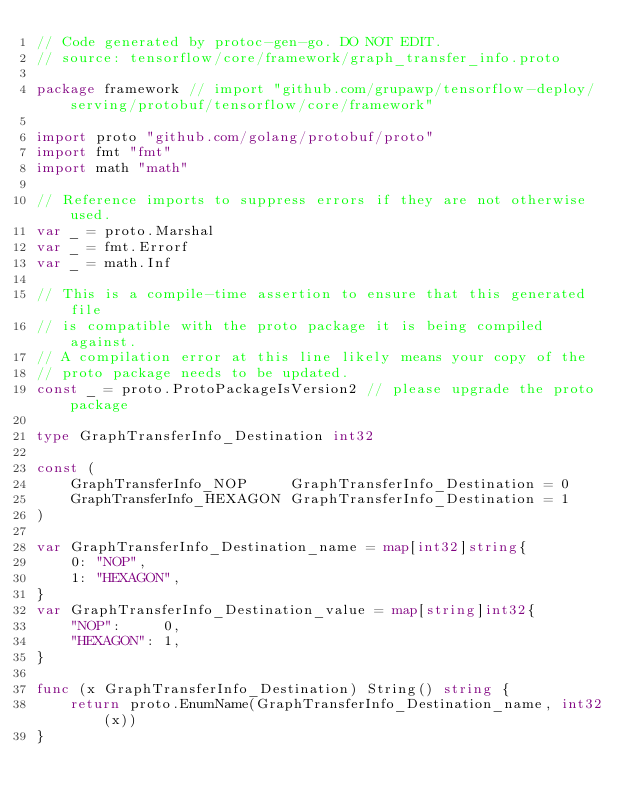<code> <loc_0><loc_0><loc_500><loc_500><_Go_>// Code generated by protoc-gen-go. DO NOT EDIT.
// source: tensorflow/core/framework/graph_transfer_info.proto

package framework // import "github.com/grupawp/tensorflow-deploy/serving/protobuf/tensorflow/core/framework"

import proto "github.com/golang/protobuf/proto"
import fmt "fmt"
import math "math"

// Reference imports to suppress errors if they are not otherwise used.
var _ = proto.Marshal
var _ = fmt.Errorf
var _ = math.Inf

// This is a compile-time assertion to ensure that this generated file
// is compatible with the proto package it is being compiled against.
// A compilation error at this line likely means your copy of the
// proto package needs to be updated.
const _ = proto.ProtoPackageIsVersion2 // please upgrade the proto package

type GraphTransferInfo_Destination int32

const (
	GraphTransferInfo_NOP     GraphTransferInfo_Destination = 0
	GraphTransferInfo_HEXAGON GraphTransferInfo_Destination = 1
)

var GraphTransferInfo_Destination_name = map[int32]string{
	0: "NOP",
	1: "HEXAGON",
}
var GraphTransferInfo_Destination_value = map[string]int32{
	"NOP":     0,
	"HEXAGON": 1,
}

func (x GraphTransferInfo_Destination) String() string {
	return proto.EnumName(GraphTransferInfo_Destination_name, int32(x))
}</code> 